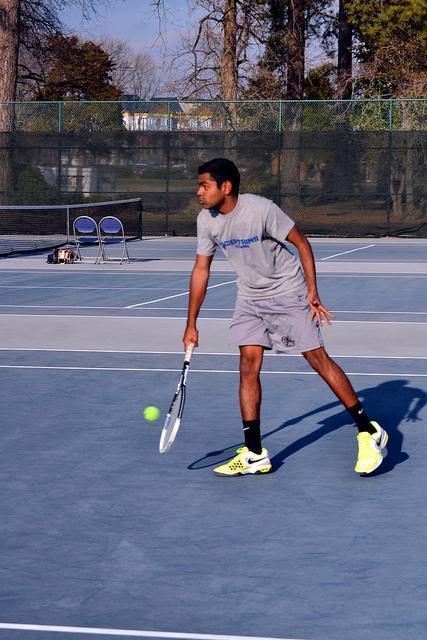Which object is in motion?
Choose the right answer from the provided options to respond to the question.
Options: Fence, chair, net, ball. Ball. 